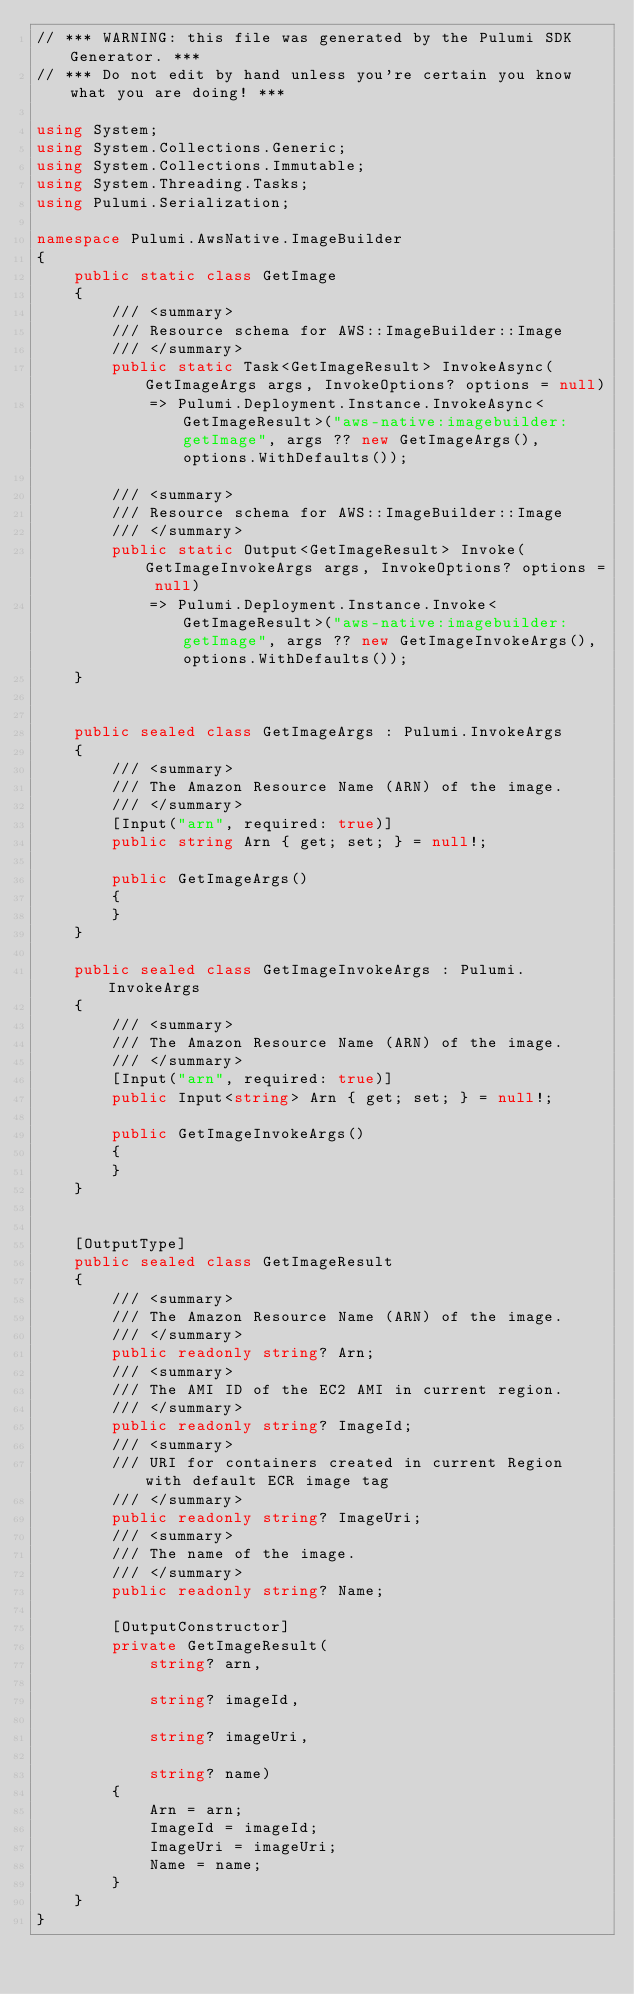<code> <loc_0><loc_0><loc_500><loc_500><_C#_>// *** WARNING: this file was generated by the Pulumi SDK Generator. ***
// *** Do not edit by hand unless you're certain you know what you are doing! ***

using System;
using System.Collections.Generic;
using System.Collections.Immutable;
using System.Threading.Tasks;
using Pulumi.Serialization;

namespace Pulumi.AwsNative.ImageBuilder
{
    public static class GetImage
    {
        /// <summary>
        /// Resource schema for AWS::ImageBuilder::Image
        /// </summary>
        public static Task<GetImageResult> InvokeAsync(GetImageArgs args, InvokeOptions? options = null)
            => Pulumi.Deployment.Instance.InvokeAsync<GetImageResult>("aws-native:imagebuilder:getImage", args ?? new GetImageArgs(), options.WithDefaults());

        /// <summary>
        /// Resource schema for AWS::ImageBuilder::Image
        /// </summary>
        public static Output<GetImageResult> Invoke(GetImageInvokeArgs args, InvokeOptions? options = null)
            => Pulumi.Deployment.Instance.Invoke<GetImageResult>("aws-native:imagebuilder:getImage", args ?? new GetImageInvokeArgs(), options.WithDefaults());
    }


    public sealed class GetImageArgs : Pulumi.InvokeArgs
    {
        /// <summary>
        /// The Amazon Resource Name (ARN) of the image.
        /// </summary>
        [Input("arn", required: true)]
        public string Arn { get; set; } = null!;

        public GetImageArgs()
        {
        }
    }

    public sealed class GetImageInvokeArgs : Pulumi.InvokeArgs
    {
        /// <summary>
        /// The Amazon Resource Name (ARN) of the image.
        /// </summary>
        [Input("arn", required: true)]
        public Input<string> Arn { get; set; } = null!;

        public GetImageInvokeArgs()
        {
        }
    }


    [OutputType]
    public sealed class GetImageResult
    {
        /// <summary>
        /// The Amazon Resource Name (ARN) of the image.
        /// </summary>
        public readonly string? Arn;
        /// <summary>
        /// The AMI ID of the EC2 AMI in current region.
        /// </summary>
        public readonly string? ImageId;
        /// <summary>
        /// URI for containers created in current Region with default ECR image tag
        /// </summary>
        public readonly string? ImageUri;
        /// <summary>
        /// The name of the image.
        /// </summary>
        public readonly string? Name;

        [OutputConstructor]
        private GetImageResult(
            string? arn,

            string? imageId,

            string? imageUri,

            string? name)
        {
            Arn = arn;
            ImageId = imageId;
            ImageUri = imageUri;
            Name = name;
        }
    }
}
</code> 